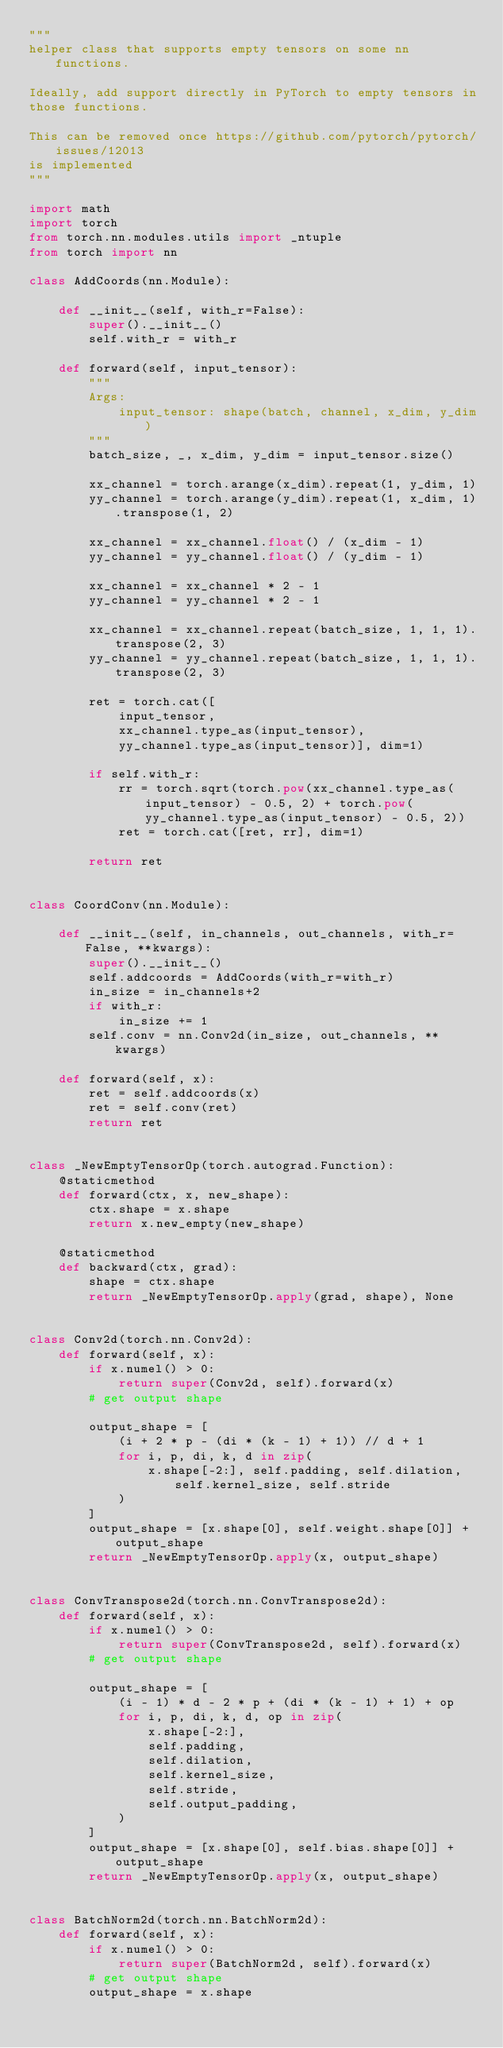<code> <loc_0><loc_0><loc_500><loc_500><_Python_>"""
helper class that supports empty tensors on some nn functions.

Ideally, add support directly in PyTorch to empty tensors in
those functions.

This can be removed once https://github.com/pytorch/pytorch/issues/12013
is implemented
"""

import math
import torch
from torch.nn.modules.utils import _ntuple
from torch import nn

class AddCoords(nn.Module):

    def __init__(self, with_r=False):
        super().__init__()
        self.with_r = with_r

    def forward(self, input_tensor):
        """
        Args:
            input_tensor: shape(batch, channel, x_dim, y_dim)
        """
        batch_size, _, x_dim, y_dim = input_tensor.size()

        xx_channel = torch.arange(x_dim).repeat(1, y_dim, 1)
        yy_channel = torch.arange(y_dim).repeat(1, x_dim, 1).transpose(1, 2)

        xx_channel = xx_channel.float() / (x_dim - 1)
        yy_channel = yy_channel.float() / (y_dim - 1)

        xx_channel = xx_channel * 2 - 1
        yy_channel = yy_channel * 2 - 1

        xx_channel = xx_channel.repeat(batch_size, 1, 1, 1).transpose(2, 3)
        yy_channel = yy_channel.repeat(batch_size, 1, 1, 1).transpose(2, 3)

        ret = torch.cat([
            input_tensor,
            xx_channel.type_as(input_tensor),
            yy_channel.type_as(input_tensor)], dim=1)

        if self.with_r:
            rr = torch.sqrt(torch.pow(xx_channel.type_as(input_tensor) - 0.5, 2) + torch.pow(yy_channel.type_as(input_tensor) - 0.5, 2))
            ret = torch.cat([ret, rr], dim=1)

        return ret


class CoordConv(nn.Module):

    def __init__(self, in_channels, out_channels, with_r=False, **kwargs):
        super().__init__()
        self.addcoords = AddCoords(with_r=with_r)
        in_size = in_channels+2
        if with_r:
            in_size += 1
        self.conv = nn.Conv2d(in_size, out_channels, **kwargs)

    def forward(self, x):
        ret = self.addcoords(x)
        ret = self.conv(ret)
        return ret


class _NewEmptyTensorOp(torch.autograd.Function):
    @staticmethod
    def forward(ctx, x, new_shape):
        ctx.shape = x.shape
        return x.new_empty(new_shape)

    @staticmethod
    def backward(ctx, grad):
        shape = ctx.shape
        return _NewEmptyTensorOp.apply(grad, shape), None


class Conv2d(torch.nn.Conv2d):
    def forward(self, x):
        if x.numel() > 0:
            return super(Conv2d, self).forward(x)
        # get output shape

        output_shape = [
            (i + 2 * p - (di * (k - 1) + 1)) // d + 1
            for i, p, di, k, d in zip(
                x.shape[-2:], self.padding, self.dilation, self.kernel_size, self.stride
            )
        ]
        output_shape = [x.shape[0], self.weight.shape[0]] + output_shape
        return _NewEmptyTensorOp.apply(x, output_shape)


class ConvTranspose2d(torch.nn.ConvTranspose2d):
    def forward(self, x):
        if x.numel() > 0:
            return super(ConvTranspose2d, self).forward(x)
        # get output shape

        output_shape = [
            (i - 1) * d - 2 * p + (di * (k - 1) + 1) + op
            for i, p, di, k, d, op in zip(
                x.shape[-2:],
                self.padding,
                self.dilation,
                self.kernel_size,
                self.stride,
                self.output_padding,
            )
        ]
        output_shape = [x.shape[0], self.bias.shape[0]] + output_shape
        return _NewEmptyTensorOp.apply(x, output_shape)


class BatchNorm2d(torch.nn.BatchNorm2d):
    def forward(self, x):
        if x.numel() > 0:
            return super(BatchNorm2d, self).forward(x)
        # get output shape
        output_shape = x.shape</code> 